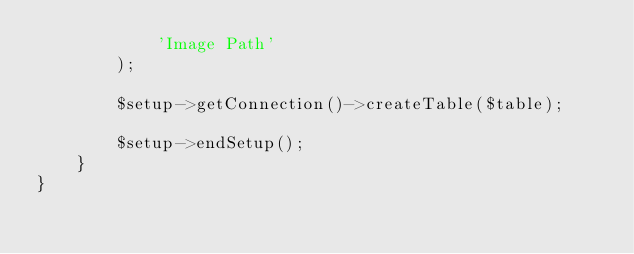<code> <loc_0><loc_0><loc_500><loc_500><_PHP_>            'Image Path'
        );

        $setup->getConnection()->createTable($table);

        $setup->endSetup();
    }
}
</code> 